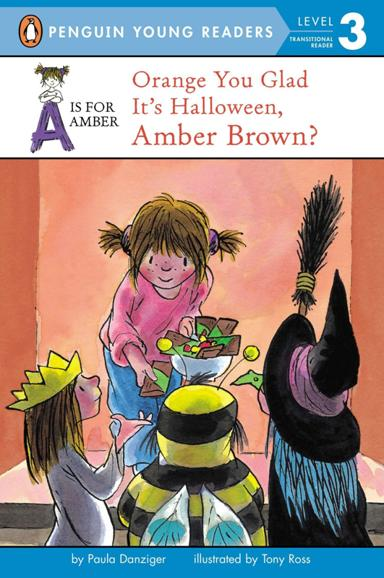What is depicted in the front cover illustration of the book? The front cover of the book illustrates a playful Halloween scene where Amber Brown, the protagonist, is interacting with two other children in costumes. This joyful portrayal sets the tone for a story filled with fun and imagination. 